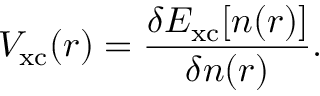Convert formula to latex. <formula><loc_0><loc_0><loc_500><loc_500>V _ { x c } ( { r } ) = \frac { \delta E _ { x c } [ n ( { r } ) ] } { \delta n ( { r } ) } .</formula> 